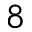<formula> <loc_0><loc_0><loc_500><loc_500>_ { 8 }</formula> 